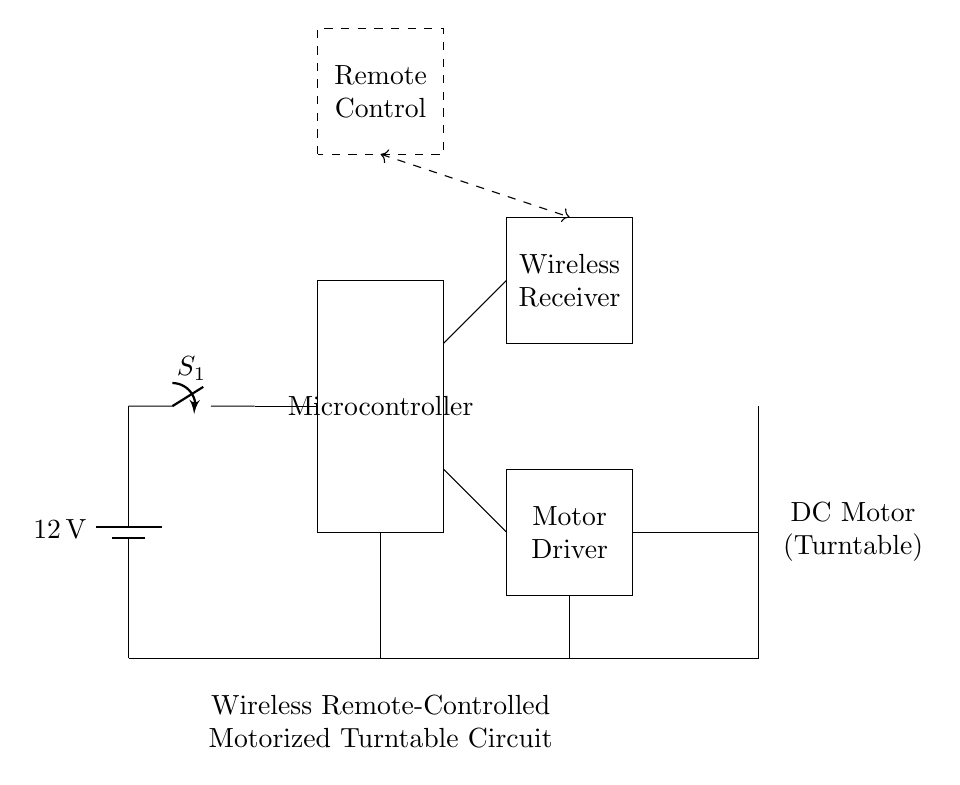What is the voltage of this circuit? The voltage is 12 volts, which is indicated by the battery symbol at the top left of the diagram.
Answer: 12 volts What type of motor is used in this circuit? The motor is a DC motor, as shown by the label next to the motor symbol.
Answer: DC motor Which component acts as the control unit? The control unit is the microcontroller, identified by the rectangle labeled "Microcontroller" in the center of the diagram.
Answer: Microcontroller How many main components are directly involved in driving the motor? There are three main components involved: the microcontroller, the motor driver, and the DC motor. Each plays a crucial role in operating the motor based on the input from the microcontroller.
Answer: Three What is the purpose of the wireless receiver in this circuit? The wireless receiver allows for remote control functionality, receiving signals from the remote control and communicating with the microcontroller to execute commands.
Answer: Remote control What component is used to toggle the power in this circuit? The power is toggled using the switch, labeled as "S1," which is connected in series with the battery at the top left of the diagram.
Answer: Switch Which part connects the microcontroller to the motor driver? The microcontroller is connected to the motor driver via two lines, which lead from the microcontroller's output to the respective inputs of the motor driver.
Answer: Two lines 